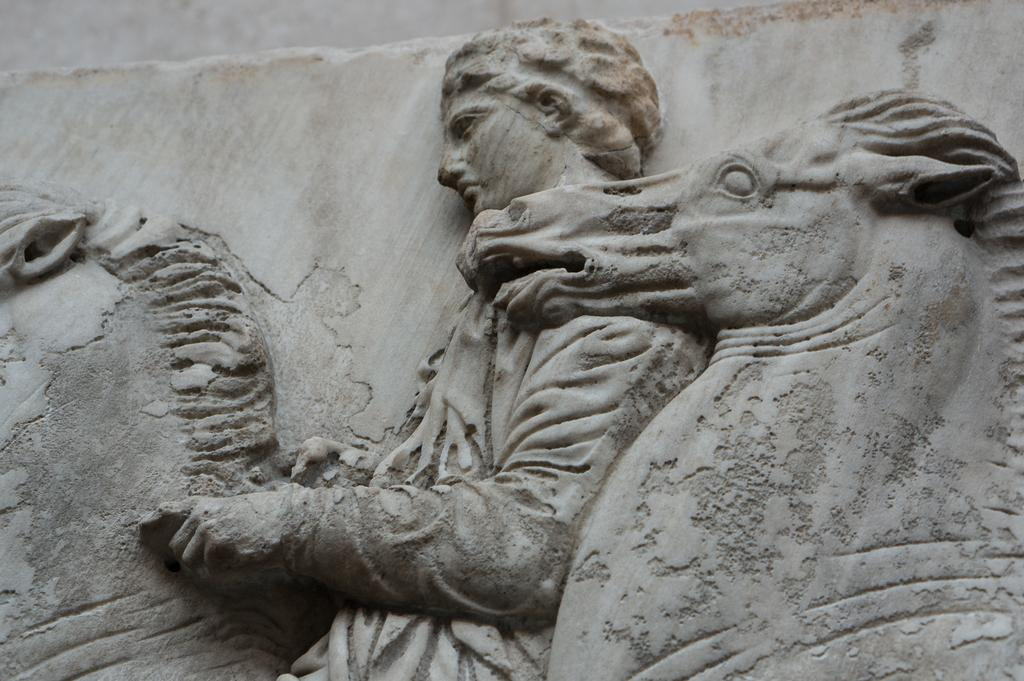What types of statues are present in the image? There is a statue of a person and a statue of an animal in the image. Where are the statues located in relation to each other? Both statues are against a wall. What color are the statues? The statues are in grey color. Can you tell me how many swings are present in the image? There are no swings present in the image; it features statues of a person and an animal against a wall. What type of cannon is depicted in the image? There is no cannon present in the image. 